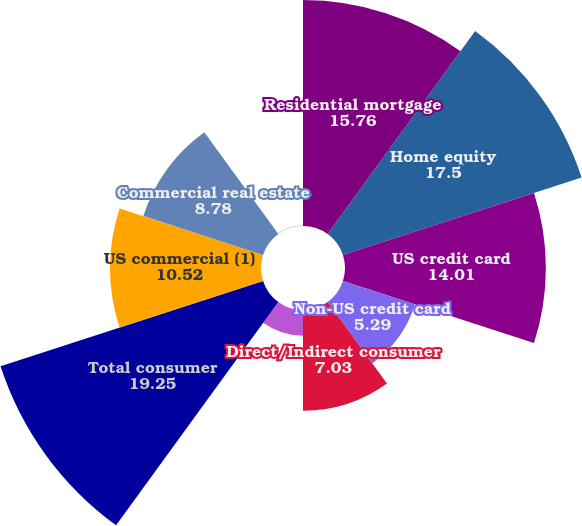Convert chart. <chart><loc_0><loc_0><loc_500><loc_500><pie_chart><fcel>Residential mortgage<fcel>Home equity<fcel>US credit card<fcel>Non-US credit card<fcel>Direct/Indirect consumer<fcel>Other consumer<fcel>Total consumer<fcel>US commercial (1)<fcel>Commercial real estate<fcel>Commercial lease financing<nl><fcel>15.76%<fcel>17.5%<fcel>14.01%<fcel>5.29%<fcel>7.03%<fcel>1.8%<fcel>19.25%<fcel>10.52%<fcel>8.78%<fcel>0.06%<nl></chart> 